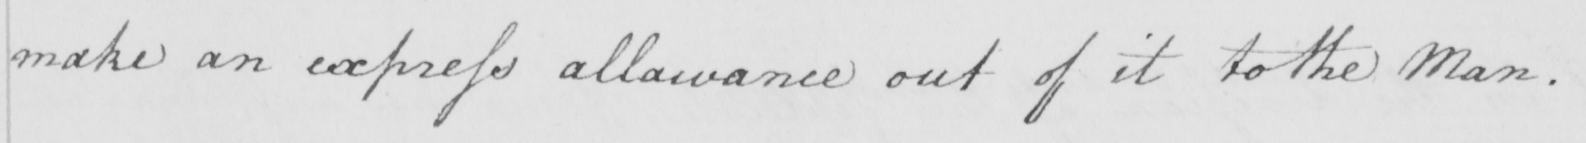What text is written in this handwritten line? make an express allowance out of it to the Man . 